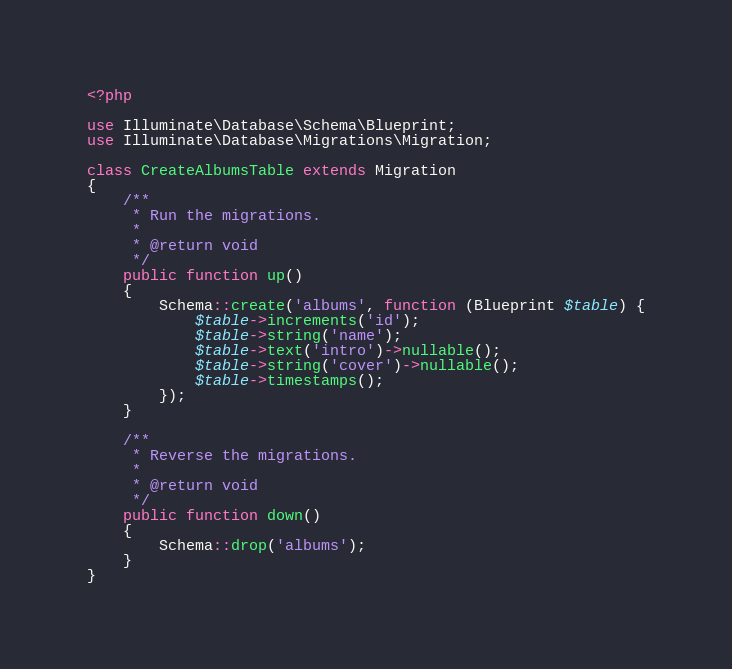Convert code to text. <code><loc_0><loc_0><loc_500><loc_500><_PHP_><?php

use Illuminate\Database\Schema\Blueprint;
use Illuminate\Database\Migrations\Migration;

class CreateAlbumsTable extends Migration
{
    /**
     * Run the migrations.
     *
     * @return void
     */
    public function up()
    {
        Schema::create('albums', function (Blueprint $table) {
            $table->increments('id');
            $table->string('name');
            $table->text('intro')->nullable();
            $table->string('cover')->nullable();
            $table->timestamps();
        });
    }

    /**
     * Reverse the migrations.
     *
     * @return void
     */
    public function down()
    {
        Schema::drop('albums');
    }
}
</code> 